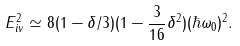<formula> <loc_0><loc_0><loc_500><loc_500>E _ { i v } ^ { 2 } \simeq 8 ( 1 - \delta / 3 ) ( 1 - \frac { 3 } { 1 6 } \delta ^ { 2 } ) ( \hbar { \omega } _ { 0 } ) ^ { 2 } .</formula> 